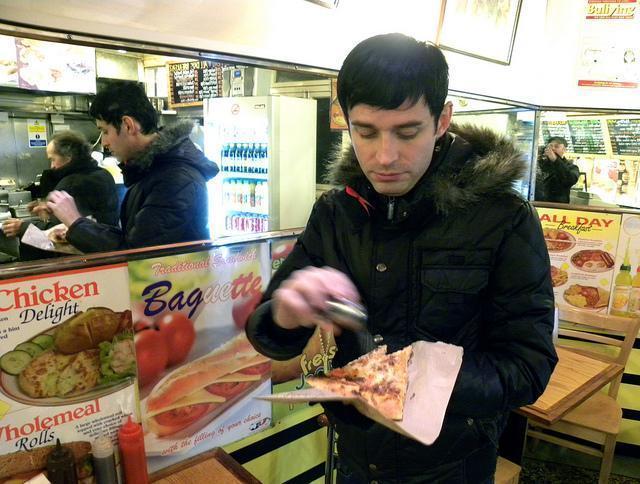What is he doing with the pizza?
Answer the question by selecting the correct answer among the 4 following choices and explain your choice with a short sentence. The answer should be formatted with the following format: `Answer: choice
Rationale: rationale.`
Options: Stealing it, adding flavor, eating it, returning it. Answer: adding flavor.
Rationale: The person is shaking a seasoning above the pizza slice. 